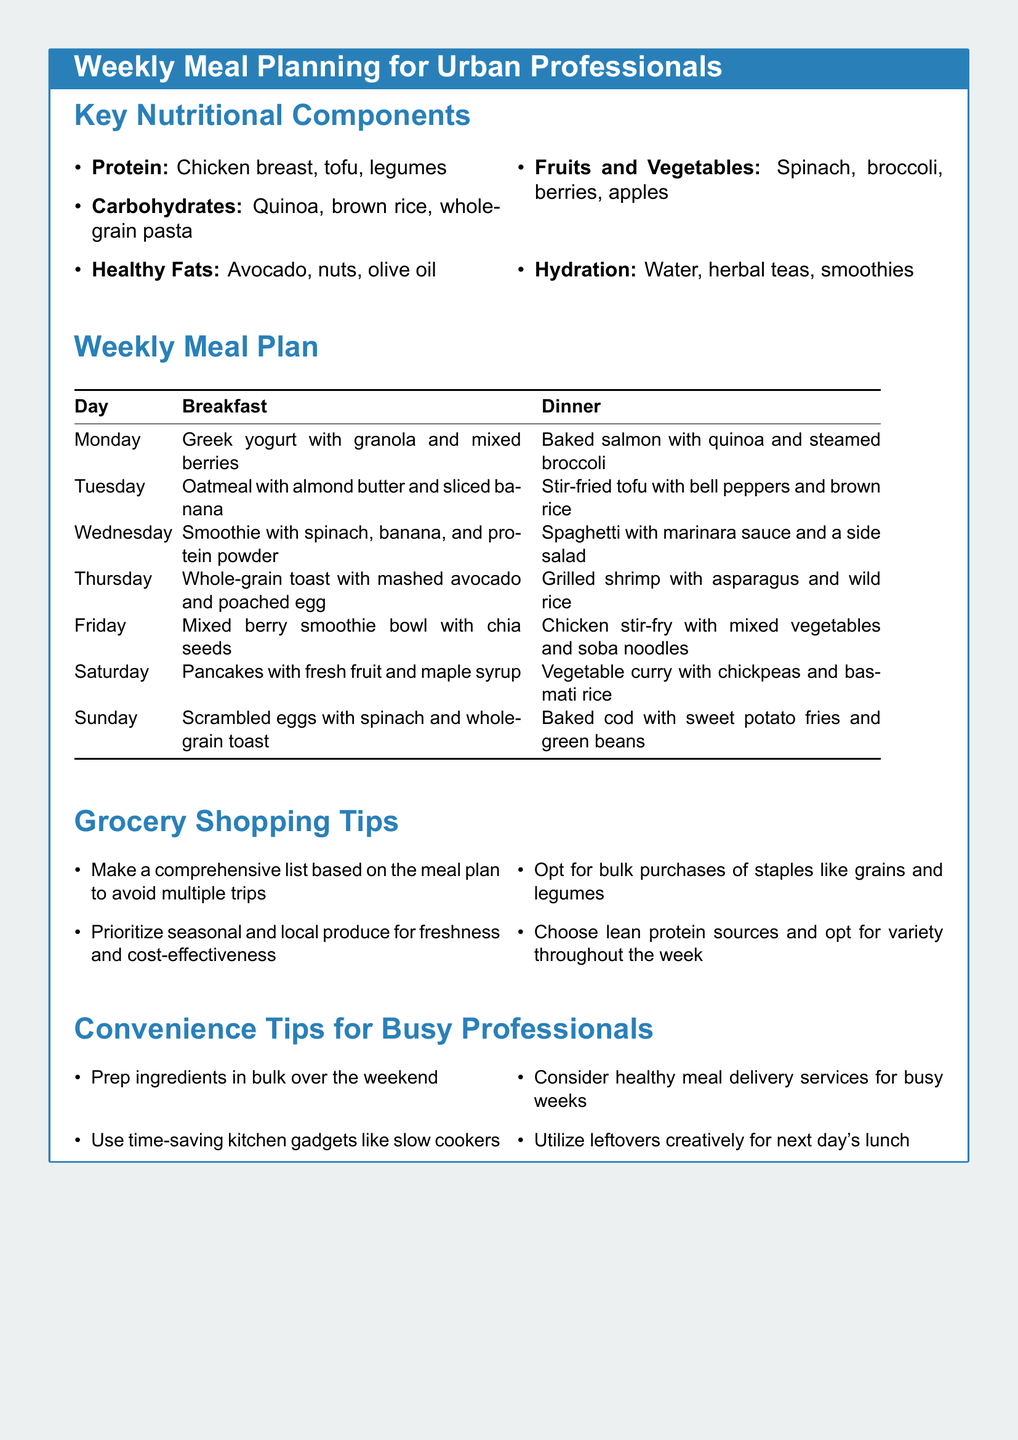What is the main focus of the document? The document provides a guide for meal planning specifically tailored for urban professionals, emphasizing nutrition and convenience.
Answer: Weekly Meal Planning for Urban Professionals What are two sources of protein mentioned? The document lists chicken breast, tofu, and legumes as sources of protein.
Answer: Chicken breast, tofu What is the breakfast option for Tuesday? The breakfast options are detailed in the weekly meal plan; Tuesday's choice is specified there.
Answer: Oatmeal with almond butter and sliced banana Which vegetable is listed for Wednesday's dinner? The dinner for Wednesday includes spaghetti with marinara sauce and a side salad, indicating vegetables.
Answer: Side salad What is one grocery shopping tip? Tips for grocery shopping focus on planning and efficiency in shopping.
Answer: Make a comprehensive list based on the meal plan How can busy professionals save time in meal prep? The convenience tips section suggests methods for efficient meal preparation suitable for busy schedules.
Answer: Prep ingredients in bulk over the weekend What grain is mentioned with the baked salmon dish? The meal plan specifies quinoa as the accompanying grain for the baked salmon dish.
Answer: Quinoa How many breakfast options are provided in the meal plan? The weekly meal plan includes breakfast options for each day of the week.
Answer: Seven 